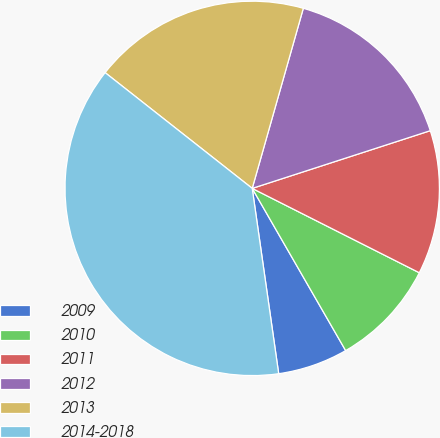<chart> <loc_0><loc_0><loc_500><loc_500><pie_chart><fcel>2009<fcel>2010<fcel>2011<fcel>2012<fcel>2013<fcel>2014-2018<nl><fcel>6.06%<fcel>9.24%<fcel>12.43%<fcel>15.61%<fcel>18.79%<fcel>37.87%<nl></chart> 